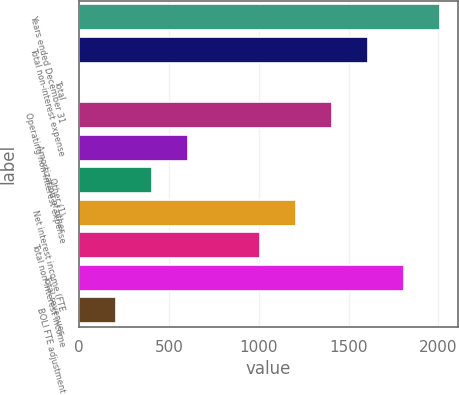<chart> <loc_0><loc_0><loc_500><loc_500><bar_chart><fcel>Years ended December 31<fcel>Total non-interest expense<fcel>Total<fcel>Operating non-interest expense<fcel>Amortization of other<fcel>Other (1)<fcel>Net interest income (FTE<fcel>Total non-interest income<fcel>Total revenues<fcel>BOLI FTE adjustment<nl><fcel>2009<fcel>1607.6<fcel>2<fcel>1406.9<fcel>604.1<fcel>403.4<fcel>1206.2<fcel>1005.5<fcel>1808.3<fcel>202.7<nl></chart> 